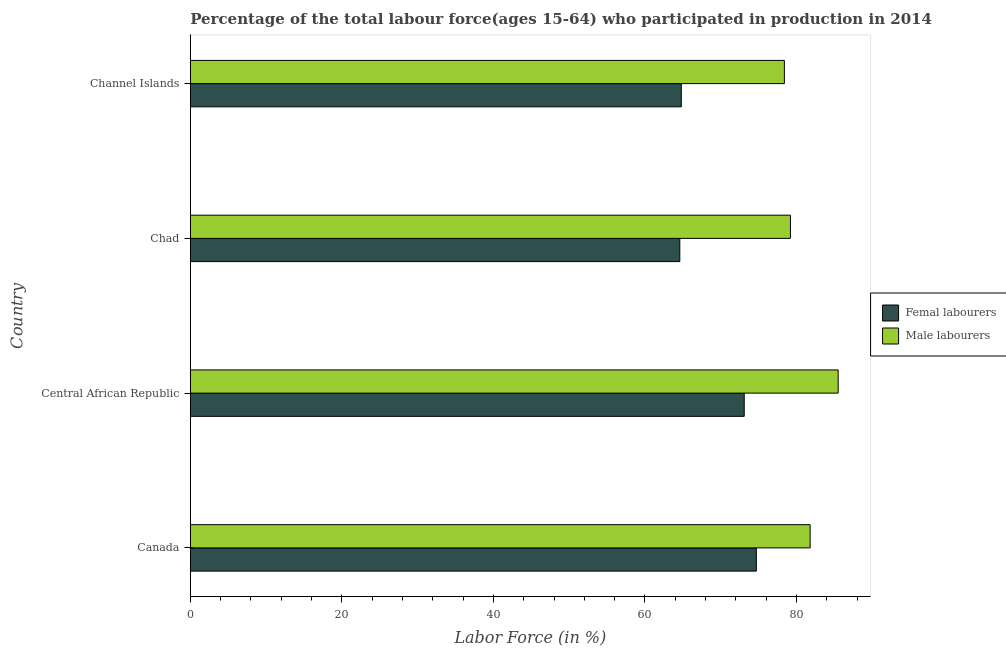How many groups of bars are there?
Provide a succinct answer. 4. What is the label of the 3rd group of bars from the top?
Ensure brevity in your answer.  Central African Republic. What is the percentage of male labour force in Channel Islands?
Offer a terse response. 78.4. Across all countries, what is the maximum percentage of male labour force?
Keep it short and to the point. 85.5. Across all countries, what is the minimum percentage of male labour force?
Your answer should be compact. 78.4. In which country was the percentage of male labour force minimum?
Keep it short and to the point. Channel Islands. What is the total percentage of male labour force in the graph?
Your response must be concise. 324.9. What is the difference between the percentage of male labour force in Central African Republic and that in Chad?
Give a very brief answer. 6.3. What is the difference between the percentage of female labor force in Central African Republic and the percentage of male labour force in Chad?
Offer a terse response. -6.1. What is the average percentage of female labor force per country?
Offer a very short reply. 69.3. What is the difference between the percentage of female labor force and percentage of male labour force in Canada?
Ensure brevity in your answer.  -7.1. In how many countries, is the percentage of male labour force greater than 80 %?
Offer a terse response. 2. What is the ratio of the percentage of female labor force in Chad to that in Channel Islands?
Your answer should be compact. 1. Is the percentage of female labor force in Canada less than that in Chad?
Provide a succinct answer. No. What is the difference between the highest and the lowest percentage of male labour force?
Your answer should be very brief. 7.1. Is the sum of the percentage of female labor force in Canada and Channel Islands greater than the maximum percentage of male labour force across all countries?
Offer a very short reply. Yes. What does the 2nd bar from the top in Central African Republic represents?
Provide a succinct answer. Femal labourers. What does the 2nd bar from the bottom in Chad represents?
Make the answer very short. Male labourers. Are all the bars in the graph horizontal?
Give a very brief answer. Yes. What is the difference between two consecutive major ticks on the X-axis?
Your answer should be very brief. 20. Are the values on the major ticks of X-axis written in scientific E-notation?
Give a very brief answer. No. How are the legend labels stacked?
Your answer should be very brief. Vertical. What is the title of the graph?
Your response must be concise. Percentage of the total labour force(ages 15-64) who participated in production in 2014. Does "Under five" appear as one of the legend labels in the graph?
Offer a terse response. No. What is the label or title of the X-axis?
Keep it short and to the point. Labor Force (in %). What is the Labor Force (in %) of Femal labourers in Canada?
Your answer should be very brief. 74.7. What is the Labor Force (in %) of Male labourers in Canada?
Make the answer very short. 81.8. What is the Labor Force (in %) of Femal labourers in Central African Republic?
Your response must be concise. 73.1. What is the Labor Force (in %) of Male labourers in Central African Republic?
Your response must be concise. 85.5. What is the Labor Force (in %) in Femal labourers in Chad?
Ensure brevity in your answer.  64.6. What is the Labor Force (in %) in Male labourers in Chad?
Offer a very short reply. 79.2. What is the Labor Force (in %) in Femal labourers in Channel Islands?
Your response must be concise. 64.8. What is the Labor Force (in %) in Male labourers in Channel Islands?
Provide a succinct answer. 78.4. Across all countries, what is the maximum Labor Force (in %) of Femal labourers?
Provide a succinct answer. 74.7. Across all countries, what is the maximum Labor Force (in %) in Male labourers?
Your response must be concise. 85.5. Across all countries, what is the minimum Labor Force (in %) of Femal labourers?
Ensure brevity in your answer.  64.6. Across all countries, what is the minimum Labor Force (in %) in Male labourers?
Your answer should be compact. 78.4. What is the total Labor Force (in %) in Femal labourers in the graph?
Offer a terse response. 277.2. What is the total Labor Force (in %) in Male labourers in the graph?
Provide a succinct answer. 324.9. What is the difference between the Labor Force (in %) in Male labourers in Canada and that in Chad?
Give a very brief answer. 2.6. What is the difference between the Labor Force (in %) in Femal labourers in Canada and that in Channel Islands?
Provide a short and direct response. 9.9. What is the difference between the Labor Force (in %) in Femal labourers in Central African Republic and that in Chad?
Your answer should be compact. 8.5. What is the difference between the Labor Force (in %) of Male labourers in Central African Republic and that in Chad?
Give a very brief answer. 6.3. What is the difference between the Labor Force (in %) in Femal labourers in Central African Republic and that in Channel Islands?
Keep it short and to the point. 8.3. What is the difference between the Labor Force (in %) in Male labourers in Central African Republic and that in Channel Islands?
Your answer should be very brief. 7.1. What is the difference between the Labor Force (in %) of Femal labourers in Chad and that in Channel Islands?
Provide a succinct answer. -0.2. What is the difference between the Labor Force (in %) in Femal labourers in Canada and the Labor Force (in %) in Male labourers in Central African Republic?
Provide a succinct answer. -10.8. What is the difference between the Labor Force (in %) of Femal labourers in Canada and the Labor Force (in %) of Male labourers in Chad?
Give a very brief answer. -4.5. What is the difference between the Labor Force (in %) in Femal labourers in Canada and the Labor Force (in %) in Male labourers in Channel Islands?
Provide a short and direct response. -3.7. What is the average Labor Force (in %) of Femal labourers per country?
Ensure brevity in your answer.  69.3. What is the average Labor Force (in %) in Male labourers per country?
Ensure brevity in your answer.  81.22. What is the difference between the Labor Force (in %) in Femal labourers and Labor Force (in %) in Male labourers in Canada?
Ensure brevity in your answer.  -7.1. What is the difference between the Labor Force (in %) of Femal labourers and Labor Force (in %) of Male labourers in Central African Republic?
Give a very brief answer. -12.4. What is the difference between the Labor Force (in %) in Femal labourers and Labor Force (in %) in Male labourers in Chad?
Give a very brief answer. -14.6. What is the ratio of the Labor Force (in %) in Femal labourers in Canada to that in Central African Republic?
Offer a terse response. 1.02. What is the ratio of the Labor Force (in %) of Male labourers in Canada to that in Central African Republic?
Your answer should be very brief. 0.96. What is the ratio of the Labor Force (in %) of Femal labourers in Canada to that in Chad?
Give a very brief answer. 1.16. What is the ratio of the Labor Force (in %) of Male labourers in Canada to that in Chad?
Provide a short and direct response. 1.03. What is the ratio of the Labor Force (in %) in Femal labourers in Canada to that in Channel Islands?
Keep it short and to the point. 1.15. What is the ratio of the Labor Force (in %) in Male labourers in Canada to that in Channel Islands?
Offer a terse response. 1.04. What is the ratio of the Labor Force (in %) of Femal labourers in Central African Republic to that in Chad?
Offer a very short reply. 1.13. What is the ratio of the Labor Force (in %) of Male labourers in Central African Republic to that in Chad?
Give a very brief answer. 1.08. What is the ratio of the Labor Force (in %) in Femal labourers in Central African Republic to that in Channel Islands?
Provide a short and direct response. 1.13. What is the ratio of the Labor Force (in %) of Male labourers in Central African Republic to that in Channel Islands?
Offer a terse response. 1.09. What is the ratio of the Labor Force (in %) in Femal labourers in Chad to that in Channel Islands?
Ensure brevity in your answer.  1. What is the ratio of the Labor Force (in %) in Male labourers in Chad to that in Channel Islands?
Provide a short and direct response. 1.01. What is the difference between the highest and the second highest Labor Force (in %) of Male labourers?
Give a very brief answer. 3.7. What is the difference between the highest and the lowest Labor Force (in %) in Male labourers?
Give a very brief answer. 7.1. 